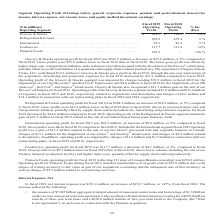According to Conagra Brands's financial document, What drove the lower gross profit for Grocery & Snacks in the fiscal year 2019 compared to in the fiscal year 2018? higher input costs, transportation inflation, and a reduction in profit associated with the divestiture of the Wesson ® oil business, partially offset by profit contribution of acquisitions and supply chain realized productivity. The document states: "fiscal 2018. The lower gross profit was driven by higher input costs, transportation inflation, and a reduction in profit associated with the divestit..." Also, How much was the sale of the Italian-based frozen pasta business, Gelit, related to the operating profit of the Refrigerated & Frozen segment in the fiscal year 2019? According to the financial document, $23.1 million. The relevant text states: "e Refrigerated & Frozen segment included a gain of $23.1 million in fiscal 2019 related to the sale of our Italian-based frozen pasta business, Gelit...." Also, What was the operating profit  of Foodservice in the fiscal year 2018 and 2019 respectively? The document shows two values: 121.8 and 117.7 (in millions). From the document: "Foodservice . 117.7 121.8 (3)% Foodservice . 117.7 121.8 (3)%..." Also, can you calculate: What is the proportion of the sale of Del Monte in International’s operating profit in the fiscal year 2019? Based on the calculation: 13.2/94.5 , the result is 0.14. This is based on the information: "International. . 94.5 86.5 9 % International. . 94.5 86.5 9 % gment fiscal 2019 operating profit was a gain of $13.2 million related to the sale of our Del Monte ® processed fruit and vegetable busine..." The key data points involved are: 13.2, 94.5. Also, can you calculate: What is the proportion of the operating profit in International and Pinnacle Foods over total operating profit in all segments in the fiscal year 2019? To answer this question, I need to perform calculations using the financial data. The calculation is: (94.5+238.2)/($689.2+502.2+94.5+117.7+238.2) , which equals 0.2. This is based on the information: "International. . 94.5 86.5 9 % Foodservice . 117.7 121.8 (3)% Pinnacle Foods. . 238.2 — 100 % Grocery & Snacks . $ 689.2 $ 724.8 (5)% Refrigerated & Frozen. . 502.2 479.4 5 %..." The key data points involved are: 117.7, 238.2, 502.2. Also, can you calculate: What is the percentage change in total operating profit of International and Foodservice from the fiscal year 2018 to 2019? To answer this question, I need to perform calculations using the financial data. The calculation is: ((94.5+117.7)-(86.5+121.8))/(86.5+121.8) , which equals 1.87 (percentage). This is based on the information: "International. . 94.5 86.5 9 % International. . 94.5 86.5 9 % Foodservice . 117.7 121.8 (3)% Foodservice . 117.7 121.8 (3)%..." The key data points involved are: 117.7, 121.8, 86.5. 